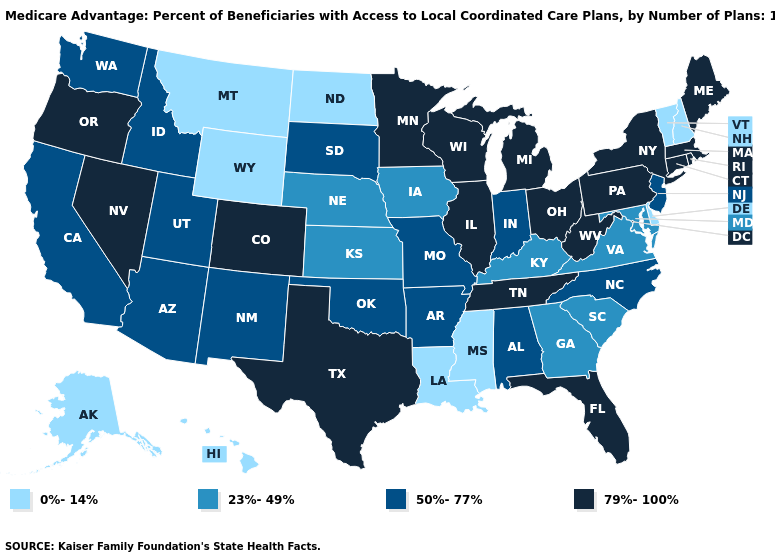Which states hav the highest value in the South?
Write a very short answer. Florida, Tennessee, Texas, West Virginia. Does the first symbol in the legend represent the smallest category?
Short answer required. Yes. What is the value of Rhode Island?
Be succinct. 79%-100%. Does the first symbol in the legend represent the smallest category?
Write a very short answer. Yes. Does the first symbol in the legend represent the smallest category?
Be succinct. Yes. Does the first symbol in the legend represent the smallest category?
Keep it brief. Yes. What is the value of California?
Quick response, please. 50%-77%. What is the lowest value in states that border Montana?
Give a very brief answer. 0%-14%. Does Louisiana have a higher value than Washington?
Quick response, please. No. What is the highest value in states that border Rhode Island?
Keep it brief. 79%-100%. Name the states that have a value in the range 0%-14%?
Be succinct. Delaware, Hawaii, Louisiana, Mississippi, Montana, North Dakota, New Hampshire, Alaska, Vermont, Wyoming. Among the states that border Oregon , does California have the lowest value?
Quick response, please. Yes. Among the states that border South Carolina , does North Carolina have the highest value?
Short answer required. Yes. What is the value of Michigan?
Write a very short answer. 79%-100%. Does West Virginia have the highest value in the USA?
Quick response, please. Yes. 